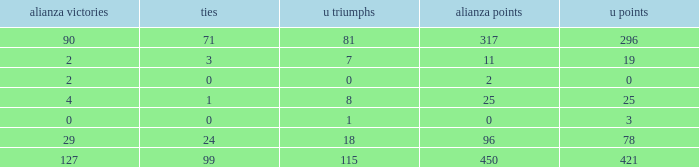What is the lowest Draws, when Alianza Goals is less than 317, when U Goals is less than 3, and when Alianza Wins is less than 2? None. 